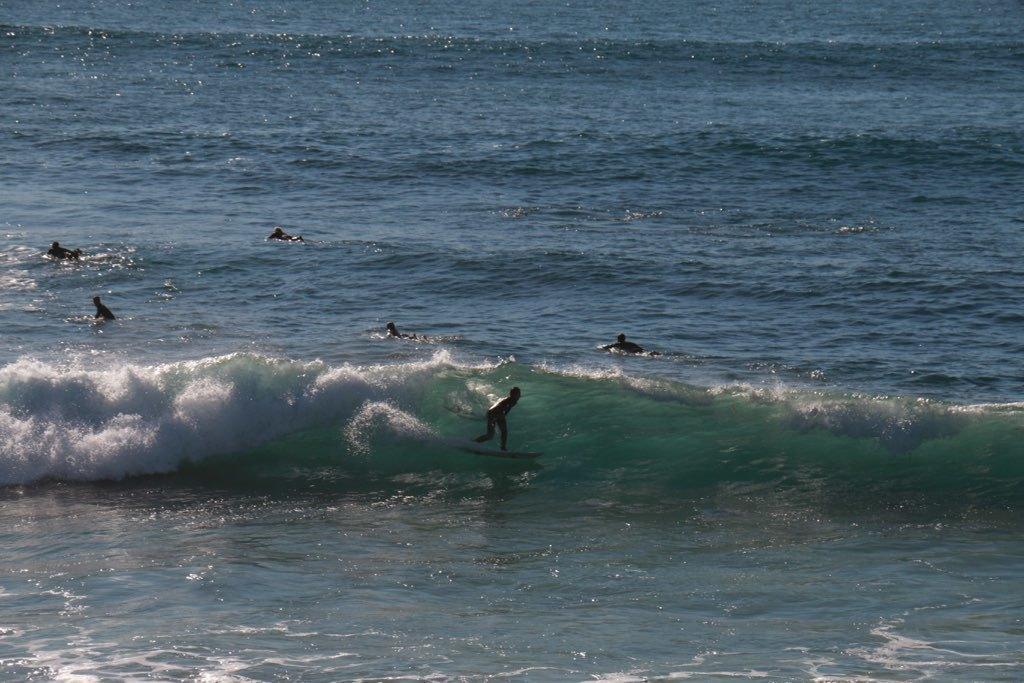In one or two sentences, can you explain what this image depicts? There are few people surfing on the water. I think this is the sea with the water flowing. This looks like a wave. 